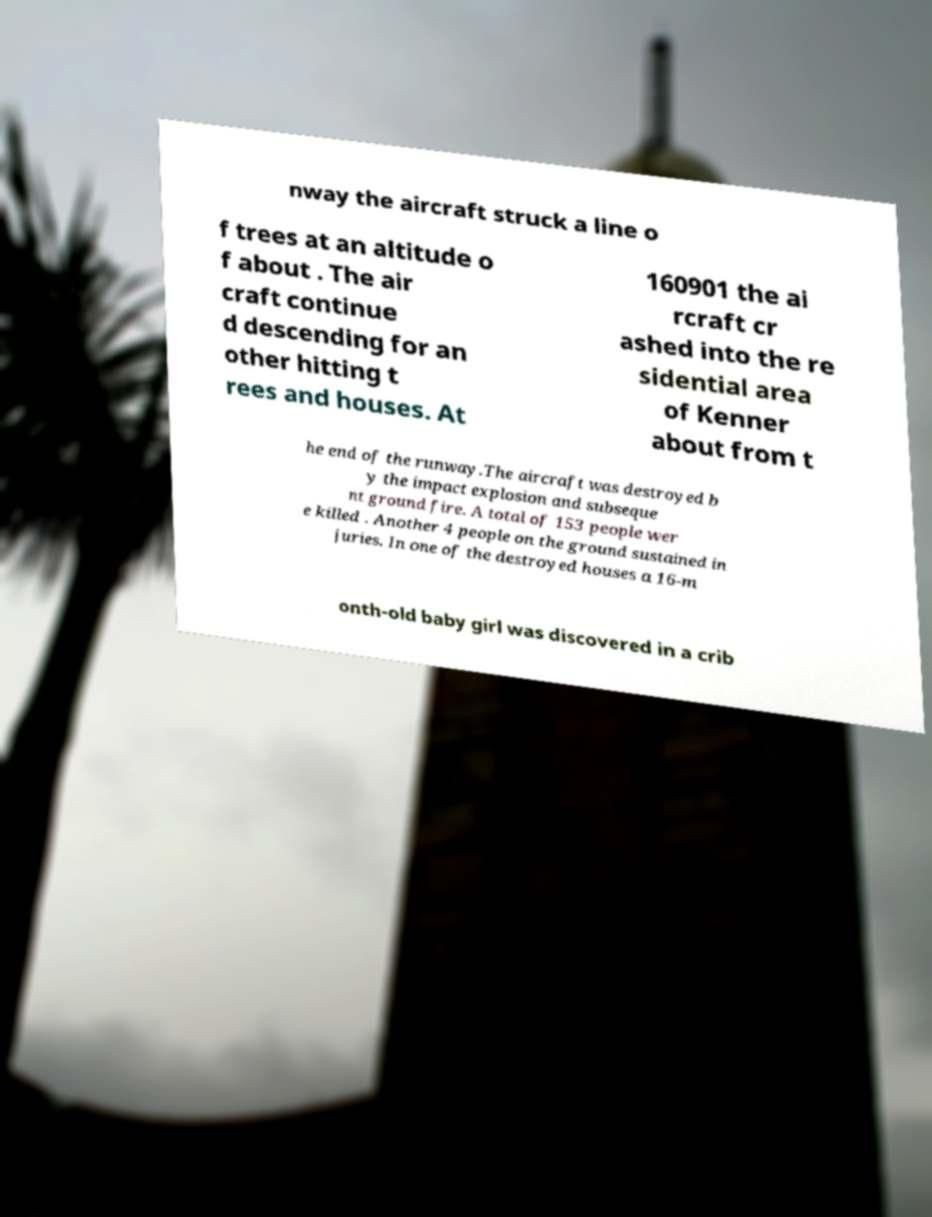Could you assist in decoding the text presented in this image and type it out clearly? nway the aircraft struck a line o f trees at an altitude o f about . The air craft continue d descending for an other hitting t rees and houses. At 160901 the ai rcraft cr ashed into the re sidential area of Kenner about from t he end of the runway.The aircraft was destroyed b y the impact explosion and subseque nt ground fire. A total of 153 people wer e killed . Another 4 people on the ground sustained in juries. In one of the destroyed houses a 16-m onth-old baby girl was discovered in a crib 